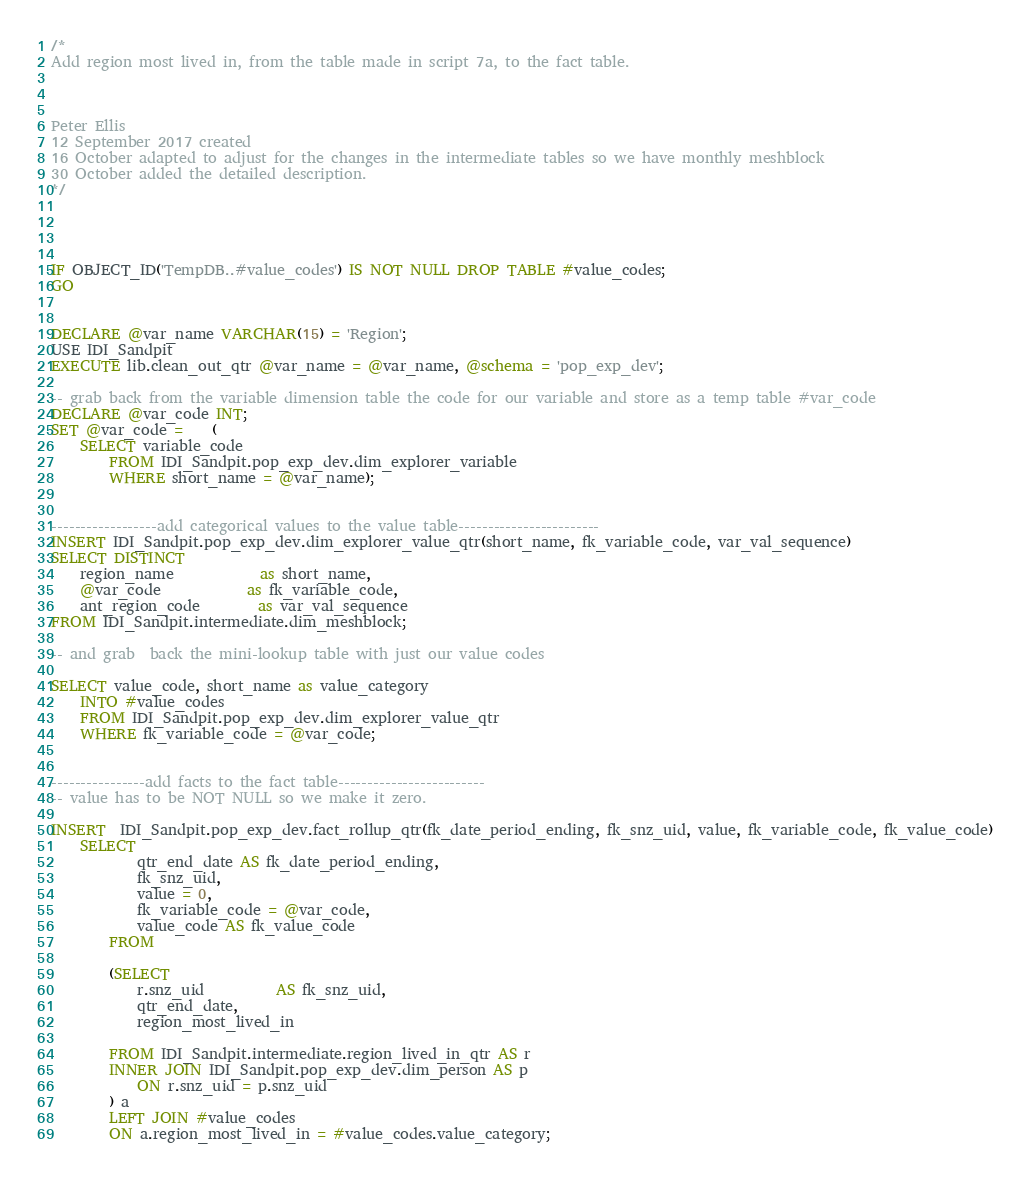Convert code to text. <code><loc_0><loc_0><loc_500><loc_500><_SQL_>/*
Add region most lived in, from the table made in script 7a, to the fact table.



Peter Ellis 
12 September 2017 created
16 October adapted to adjust for the changes in the intermediate tables so we have monthly meshblock
30 October added the detailed description.
*/




IF OBJECT_ID('TempDB..#value_codes') IS NOT NULL DROP TABLE #value_codes;
GO 


DECLARE @var_name VARCHAR(15) = 'Region';
USE IDI_Sandpit
EXECUTE lib.clean_out_qtr @var_name = @var_name, @schema = 'pop_exp_dev';

-- grab back from the variable dimension table the code for our variable and store as a temp table #var_code			 
DECLARE @var_code INT;
SET @var_code =	(
	SELECT variable_code
		FROM IDI_Sandpit.pop_exp_dev.dim_explorer_variable
		WHERE short_name = @var_name);


------------------add categorical values to the value table------------------------
INSERT IDI_Sandpit.pop_exp_dev.dim_explorer_value_qtr(short_name, fk_variable_code, var_val_sequence)
SELECT DISTINCT
	region_name			as short_name,
	@var_code			as fk_variable_code,
	ant_region_code		as var_val_sequence
FROM IDI_Sandpit.intermediate.dim_meshblock;

-- and grab  back the mini-lookup table with just our value codes

SELECT value_code, short_name as value_category
	INTO #value_codes
	FROM IDI_Sandpit.pop_exp_dev.dim_explorer_value_qtr 
	WHERE fk_variable_code = @var_code;
	
	
----------------add facts to the fact table-------------------------
-- value has to be NOT NULL so we make it zero.  

INSERT  IDI_Sandpit.pop_exp_dev.fact_rollup_qtr(fk_date_period_ending, fk_snz_uid, value, fk_variable_code, fk_value_code)
	SELECT 
			qtr_end_date AS fk_date_period_ending, 
			fk_snz_uid, 
			value = 0,
			fk_variable_code = @var_code,
			value_code AS fk_value_code
		FROM
				
		(SELECT
			r.snz_uid          AS fk_snz_uid,
			qtr_end_date,
			region_most_lived_in
			
		FROM IDI_Sandpit.intermediate.region_lived_in_qtr AS r
		INNER JOIN IDI_Sandpit.pop_exp_dev.dim_person AS p
			ON r.snz_uid = p.snz_uid
		) a
		LEFT JOIN #value_codes 
		ON a.region_most_lived_in = #value_codes.value_category;




</code> 